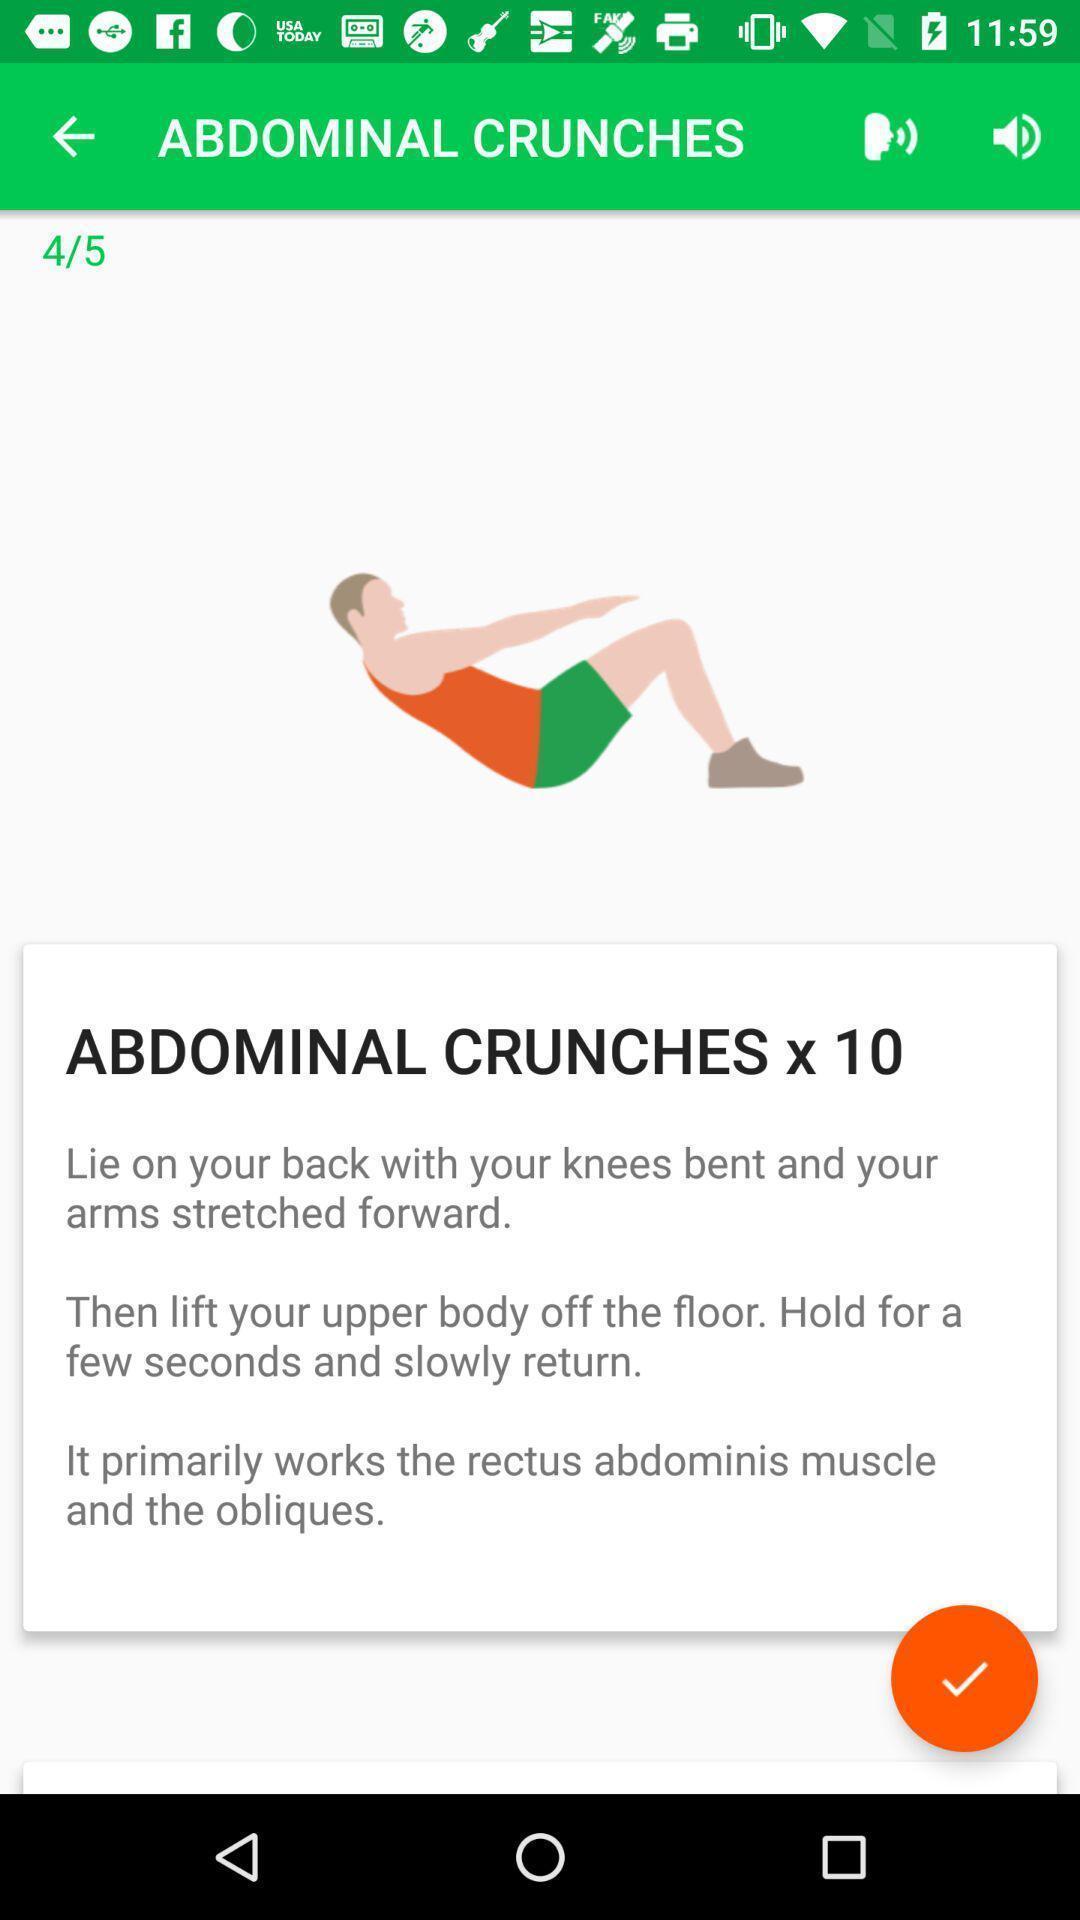Explain the elements present in this screenshot. Screen shows text message in a fitness app. 